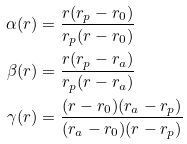Convert formula to latex. <formula><loc_0><loc_0><loc_500><loc_500>\alpha ( r ) & = \frac { r ( r _ { p } - r _ { 0 } ) } { r _ { p } ( r - r _ { 0 } ) } \\ \beta ( r ) & = \frac { r ( r _ { p } - r _ { a } ) } { r _ { p } ( r - r _ { a } ) } \\ \gamma ( r ) & = \frac { ( r - r _ { 0 } ) ( r _ { a } - r _ { p } ) } { ( r _ { a } - r _ { 0 } ) ( r - r _ { p } ) }</formula> 